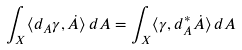<formula> <loc_0><loc_0><loc_500><loc_500>\int _ { X } \langle d _ { A } \gamma , \dot { A } \rangle \, d A = \int _ { X } \langle \gamma , d _ { A } ^ { * } \dot { A } \rangle \, d A</formula> 